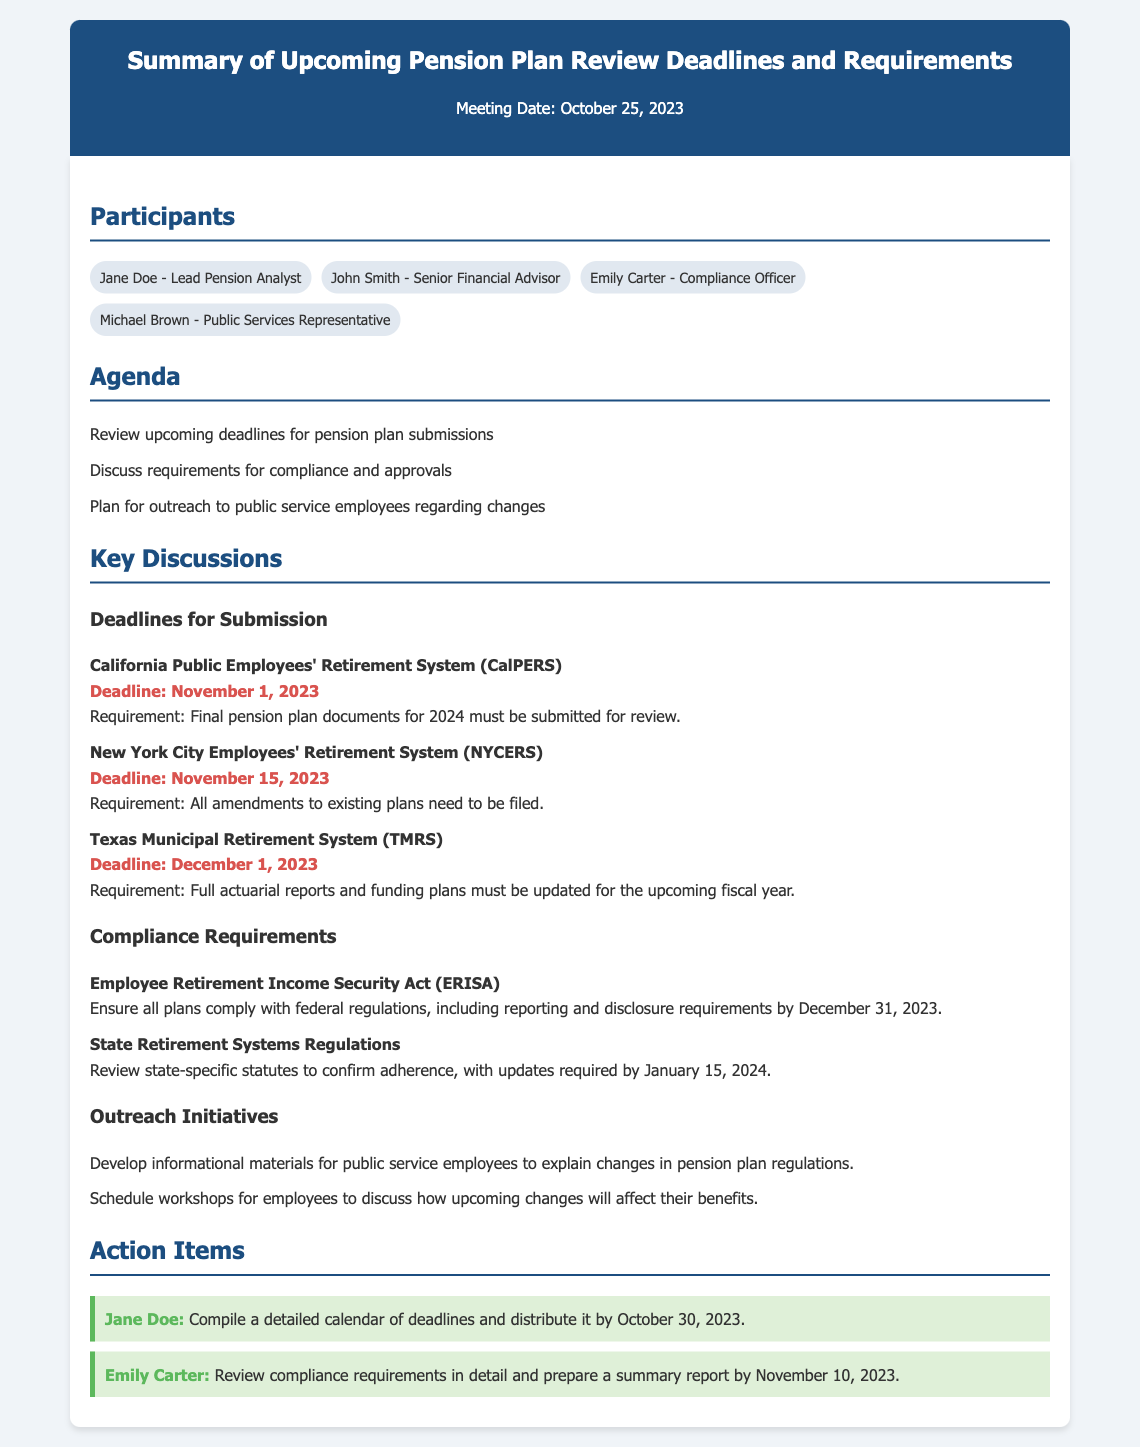What is the meeting date? The meeting date is explicitly stated in the document under the header.
Answer: October 25, 2023 Who is the lead pension analyst? The lead pension analyst is listed among the participants.
Answer: Jane Doe What is the deadline for CalPERS submissions? The deadline for CalPERS submissions is specified in the deadlines section.
Answer: November 1, 2023 What must be submitted for the TMRS deadline? The requirements for TMRS are detailed in the document's deadlines section.
Answer: Full actuarial reports and funding plans Who is responsible for compiling the calendar of deadlines? The action item specifies who is responsible for this task.
Answer: Jane Doe What is the compliance requirement deadline for ERISA? The deadline for ERISA compliance requirements is stated clearly in the document.
Answer: December 31, 2023 What type of materials will be developed for outreach initiatives? The types of materials are described under outreach initiatives.
Answer: Informational materials How many days do we have until the NYCERS deadline? The document mentions the NYCERS deadline, allowing for a simple calculation based on the meeting date.
Answer: 21 days What is the first action item mentioned in the document? The first action item is outlined and attributed to a specific participant.
Answer: Compile a detailed calendar of deadlines and distribute it by October 30, 2023 